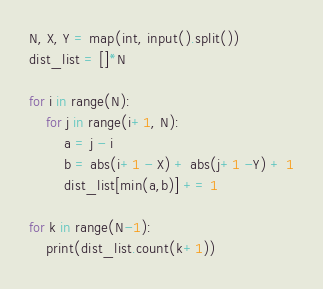Convert code to text. <code><loc_0><loc_0><loc_500><loc_500><_Python_>N, X, Y = map(int, input().split())
dist_list = []*N

for i in range(N):
    for j in range(i+1, N):
        a = j - i
        b = abs(i+1 - X) + abs(j+1 -Y) + 1
        dist_list[min(a,b)] += 1
        
for k in range(N-1):
    print(dist_list.count(k+1))

</code> 